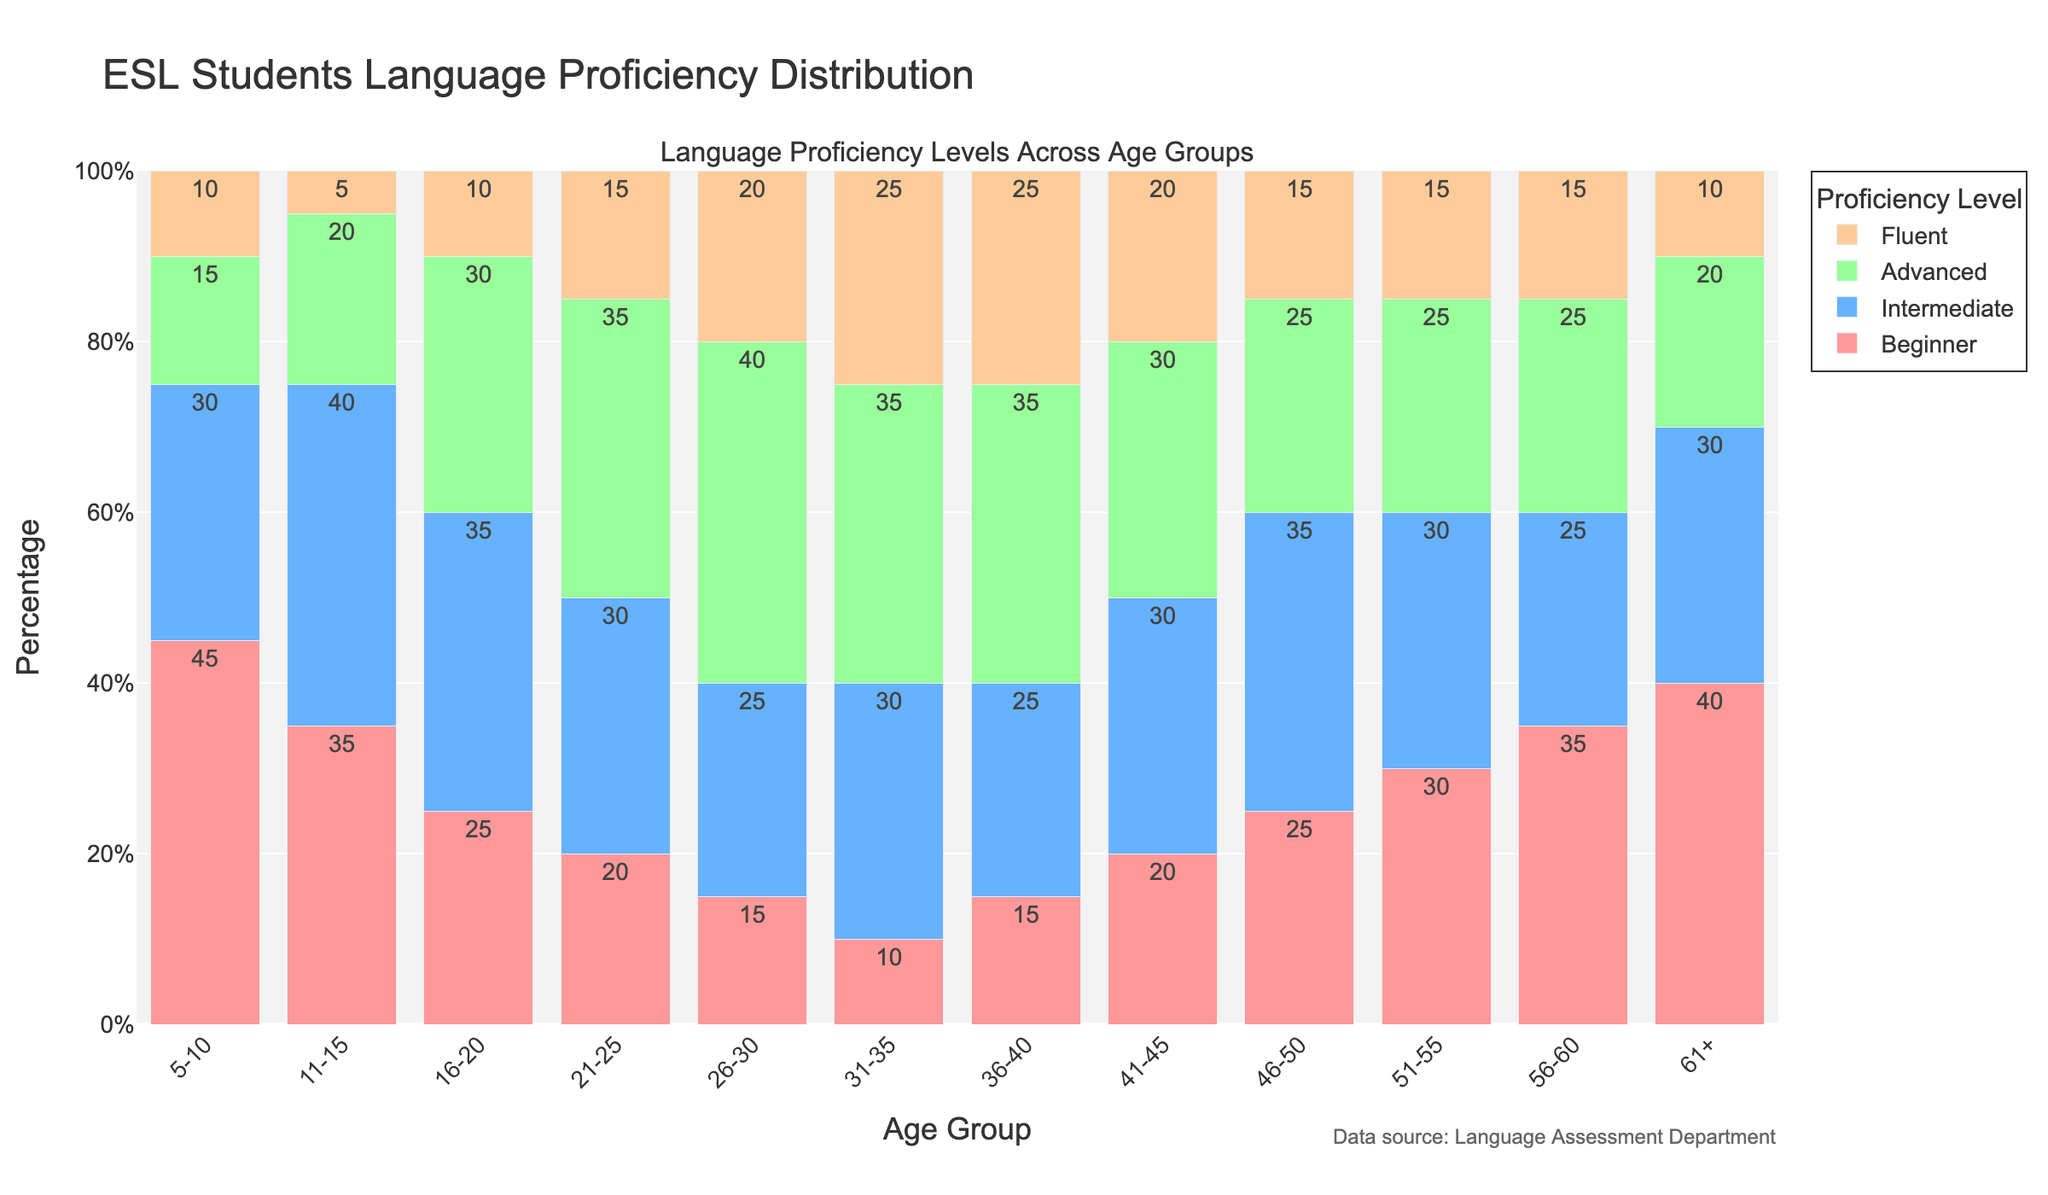What age group has the highest percentage of Fluent proficiency? To determine this, look at the height of the bars indicating Fluent proficiency. The age group 31-35 has the tallest bar for Fluent proficiency, indicating the highest percentage.
Answer: 31-35 Which age group has the highest percentage of Beginner proficiency? Check the height of the bars representing Beginner proficiency. The age group 5-10 has the tallest bar, indicating it has the highest percentage of Beginner proficiency.
Answer: 5-10 Which two age groups have the same percentage of Advanced proficiency? Compare the height of the bars representing Advanced proficiency for each age group. The age groups 31-35 and 36-40 both have the same height for Advanced proficiency.
Answer: 31-35 and 36-40 What is the total percentage of Intermediate proficiency across all age groups? Sum the percentage values for Intermediate proficiency from each age group: 30 + 40 + 35 + 30 + 25 + 30 + 25 + 30 + 35 + 30 + 25 + 30. The total is 365%.
Answer: 365% In which age group is the percentage of Fluent proficiency the lowest? Check the height of the bars indicating Fluent proficiency. The age group 11-15 has the lowest bar for Fluent proficiency, indicating the lowest percentage.
Answer: 11-15 How does the percentage of Advanced proficiency in the 26-30 age group compare to that in the 46-50 age group? Compare the heights of the bars for Advanced proficiency in the age groups 26-30 and 46-50. The age group 26-30 has a higher percentage than the age group 46-50 for Advanced proficiency.
Answer: Higher in 26-30 What is the average percentage of Fluent proficiency across all age groups? Calculate the sum of the percentages for Fluent proficiency across all age groups, then divide by the number of age groups. Sum: 10 + 5 + 10 + 15 + 20 + 25 + 25 + 20 + 15 + 15 + 15 + 10 = 185. Average: 185 / 12 ≈ 15.42%.
Answer: ≈ 15.42% Which proficiency level shows a consistently decreasing trend across age groups? Check each proficiency level's percentage changes across age groups. The Beginner proficiency shows a consistently decreasing trend from younger to older age groups.
Answer: Beginner What is the range of Intermediate proficiency percentages across the age groups? Determine the minimum and maximum percentages for Intermediate proficiency. The minimum is 25% (for several age groups), and the maximum is 40% (for age group 11-15). Range: 40% - 25% = 15%.
Answer: 15% What is the combined percentage of Advanced and Fluent proficiency in the age group 21-25? Add the percentages for Advanced and Fluent proficiency in the age group 21-25. Advanced: 35%, Fluent: 15%. Combined: 35% + 15% = 50%.
Answer: 50% 